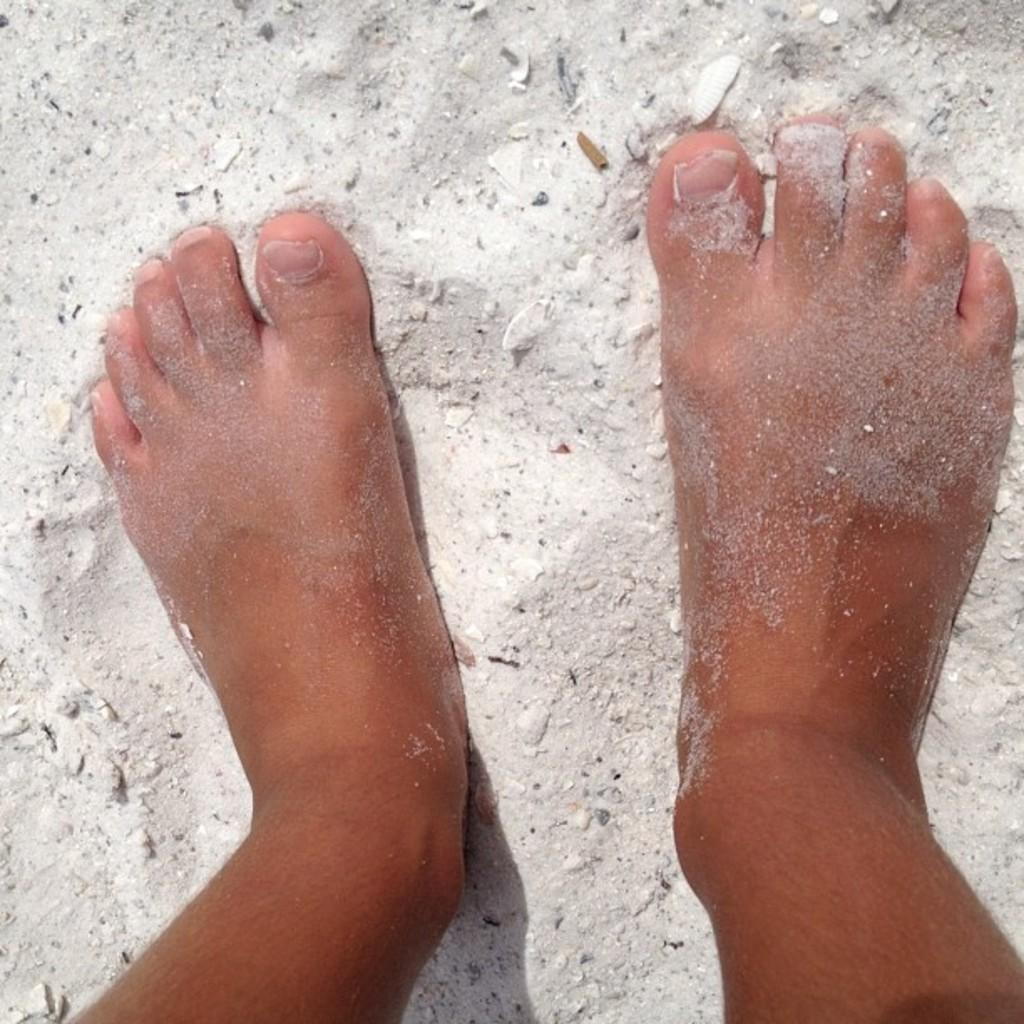What body part can be seen in the image? Human feet are visible in the image. What type of terrain is present in the image? The land is sandy. What type of education is being discussed in the image? There is no discussion or indication of education in the image; it only shows human feet and sandy land. 